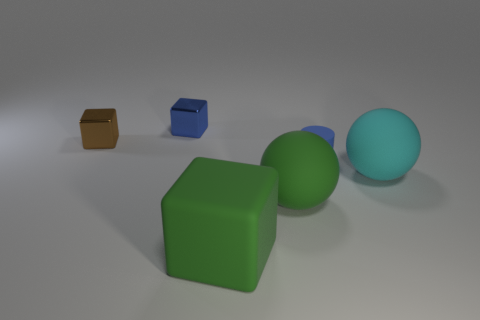Add 1 brown cubes. How many objects exist? 7 Subtract all cylinders. How many objects are left? 5 Add 5 small blue cubes. How many small blue cubes are left? 6 Add 4 big cyan shiny blocks. How many big cyan shiny blocks exist? 4 Subtract 0 cyan cylinders. How many objects are left? 6 Subtract all tiny blue metal objects. Subtract all large green matte cubes. How many objects are left? 4 